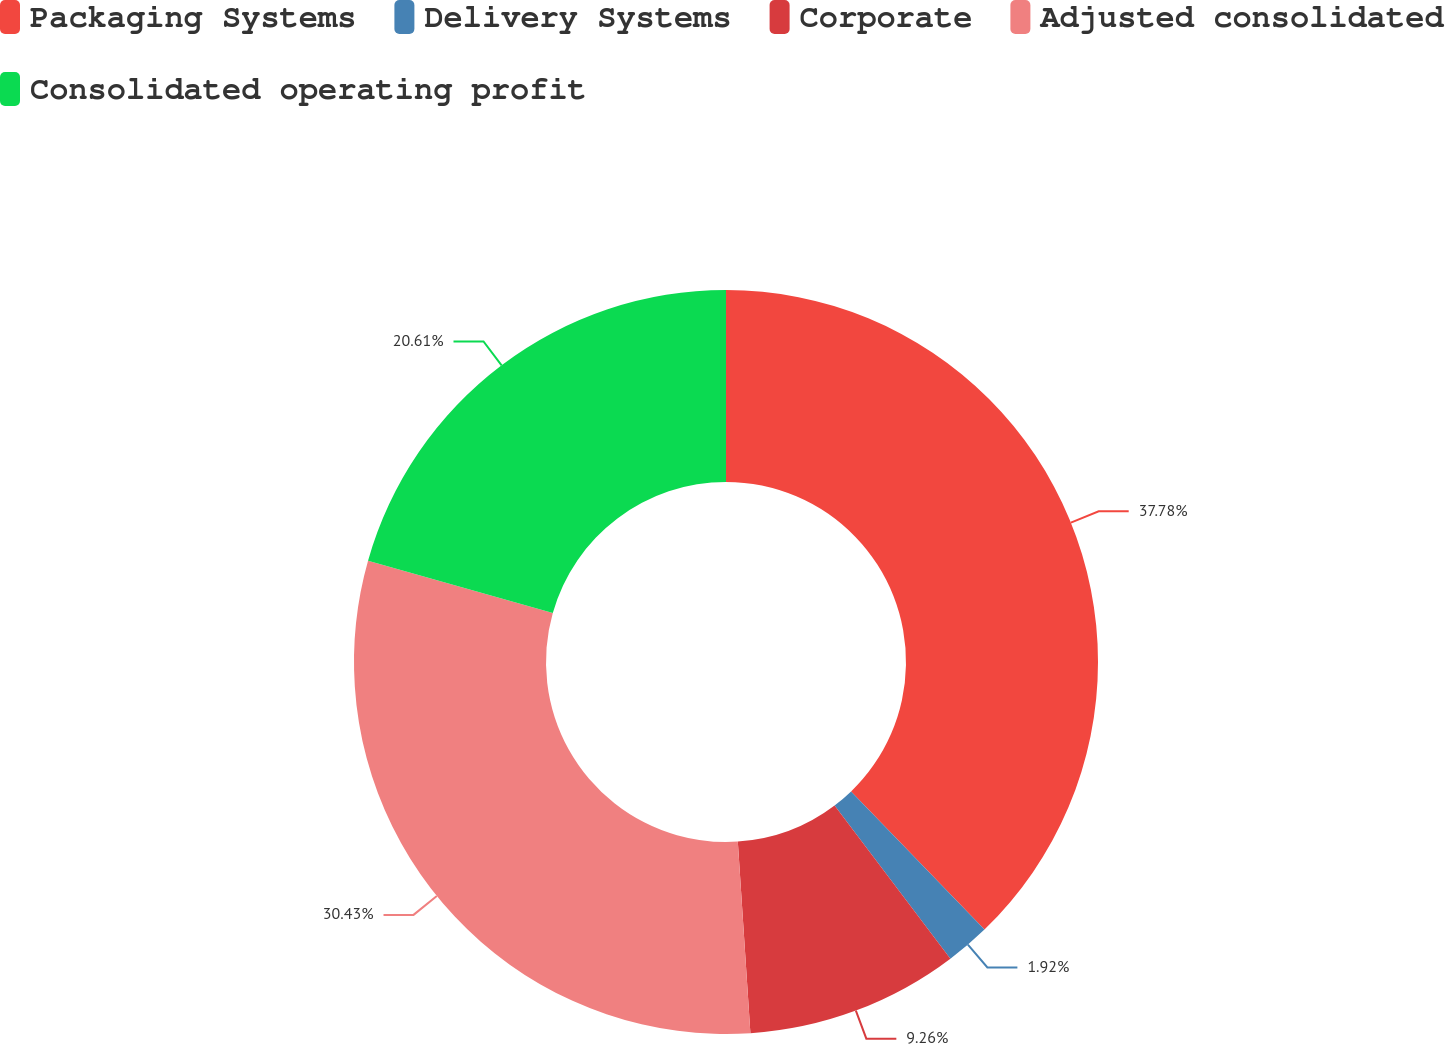<chart> <loc_0><loc_0><loc_500><loc_500><pie_chart><fcel>Packaging Systems<fcel>Delivery Systems<fcel>Corporate<fcel>Adjusted consolidated<fcel>Consolidated operating profit<nl><fcel>37.77%<fcel>1.92%<fcel>9.26%<fcel>30.43%<fcel>20.61%<nl></chart> 